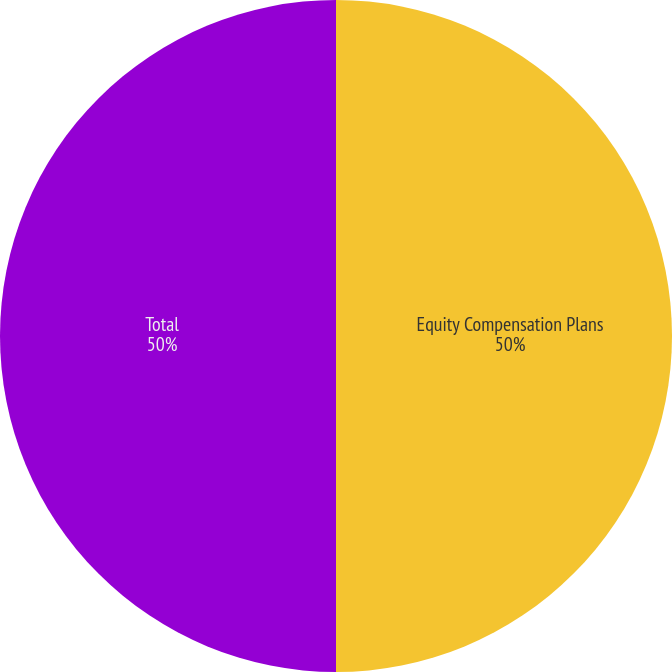Convert chart. <chart><loc_0><loc_0><loc_500><loc_500><pie_chart><fcel>Equity Compensation Plans<fcel>Total<nl><fcel>50.0%<fcel>50.0%<nl></chart> 